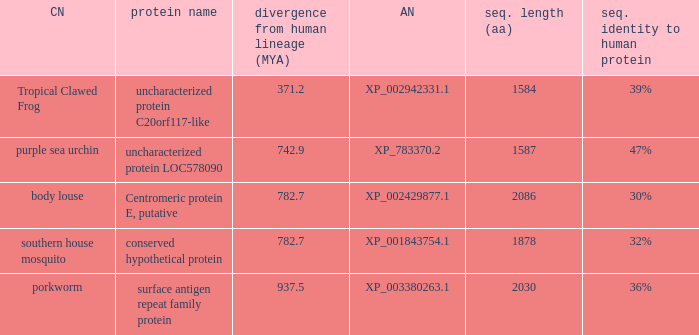What is the accession number of the protein with a divergence from human lineage of 937.5? XP_003380263.1. 